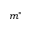<formula> <loc_0><loc_0><loc_500><loc_500>m ^ { * }</formula> 